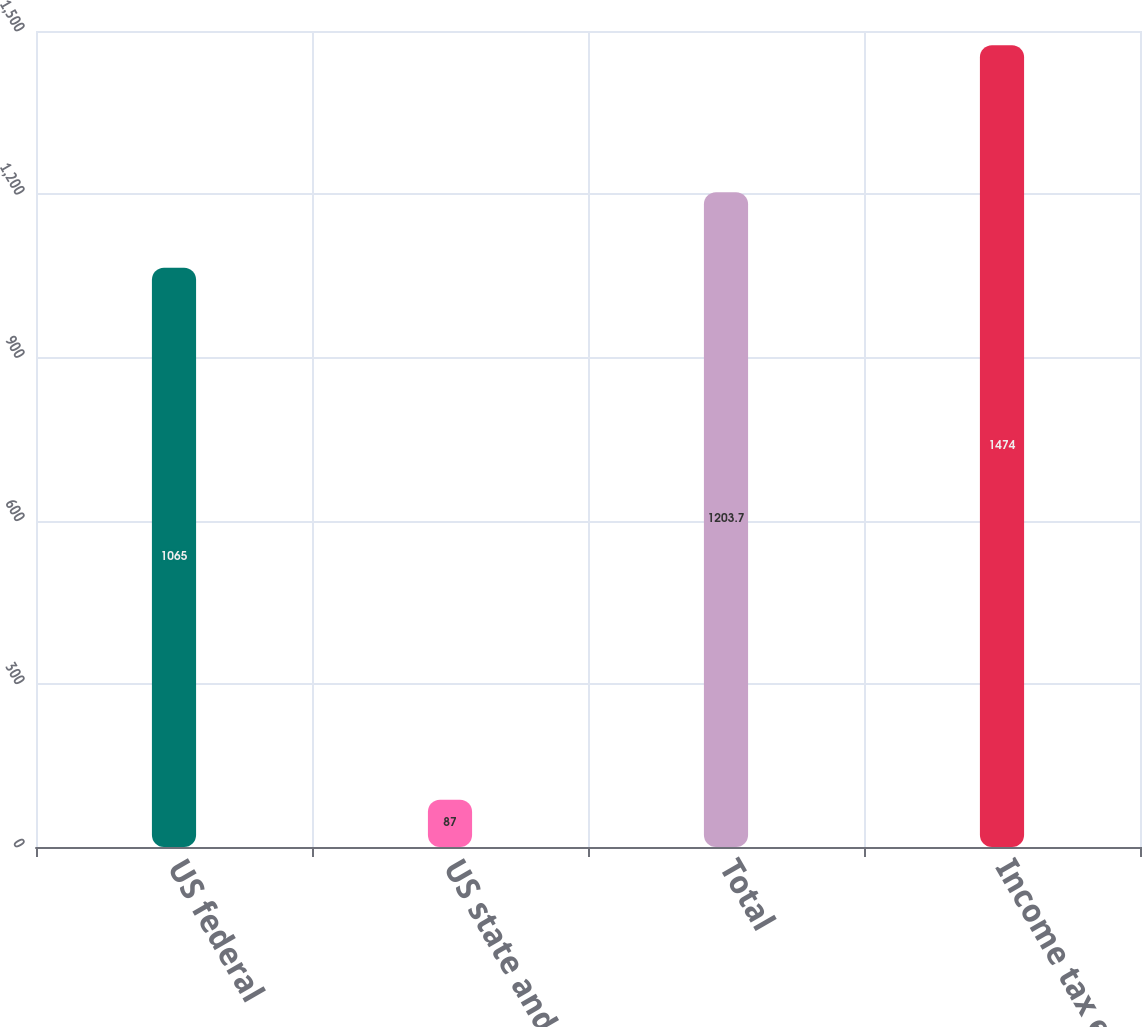Convert chart. <chart><loc_0><loc_0><loc_500><loc_500><bar_chart><fcel>US federal<fcel>US state and local<fcel>Total<fcel>Income tax expense<nl><fcel>1065<fcel>87<fcel>1203.7<fcel>1474<nl></chart> 